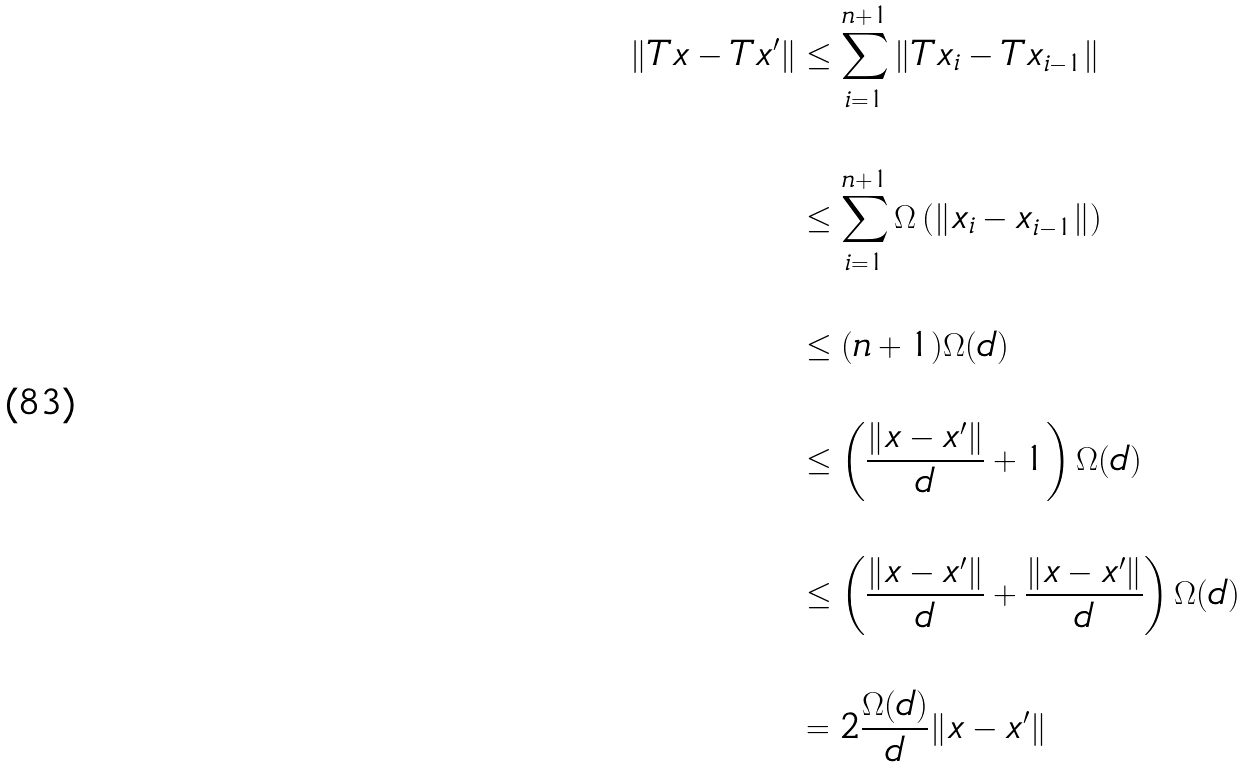<formula> <loc_0><loc_0><loc_500><loc_500>\| T x - T x ^ { \prime } \| & \leq \sum _ { i = 1 } ^ { n + 1 } \| T x _ { i } - T x _ { i - 1 } \| \\ & \\ & \leq \sum _ { i = 1 } ^ { n + 1 } \Omega \left ( \| x _ { i } - x _ { i - 1 } \| \right ) \\ & \\ & \leq ( n + 1 ) \Omega ( d ) \\ & \\ & \leq \left ( \frac { \| x - x ^ { \prime } \| } { d } + 1 \right ) \Omega ( d ) \\ & \\ & \leq \left ( \frac { \| x - x ^ { \prime } \| } { d } + \frac { \| x - x ^ { \prime } \| } { d } \right ) \Omega ( d ) \\ & \\ & = 2 \frac { \Omega ( d ) } { d } \| x - x ^ { \prime } \| \\ & \\</formula> 